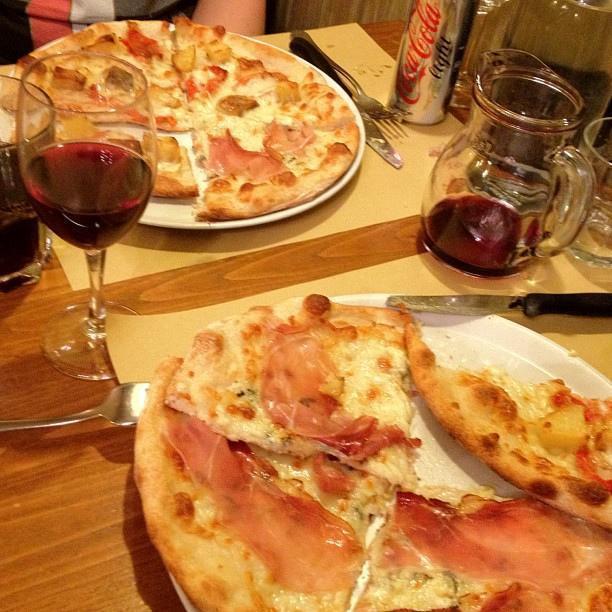Where would you most likely see this type of pizza served with wine?
Make your selection from the four choices given to correctly answer the question.
Options: Uk, canada, italy, usa. Italy. 